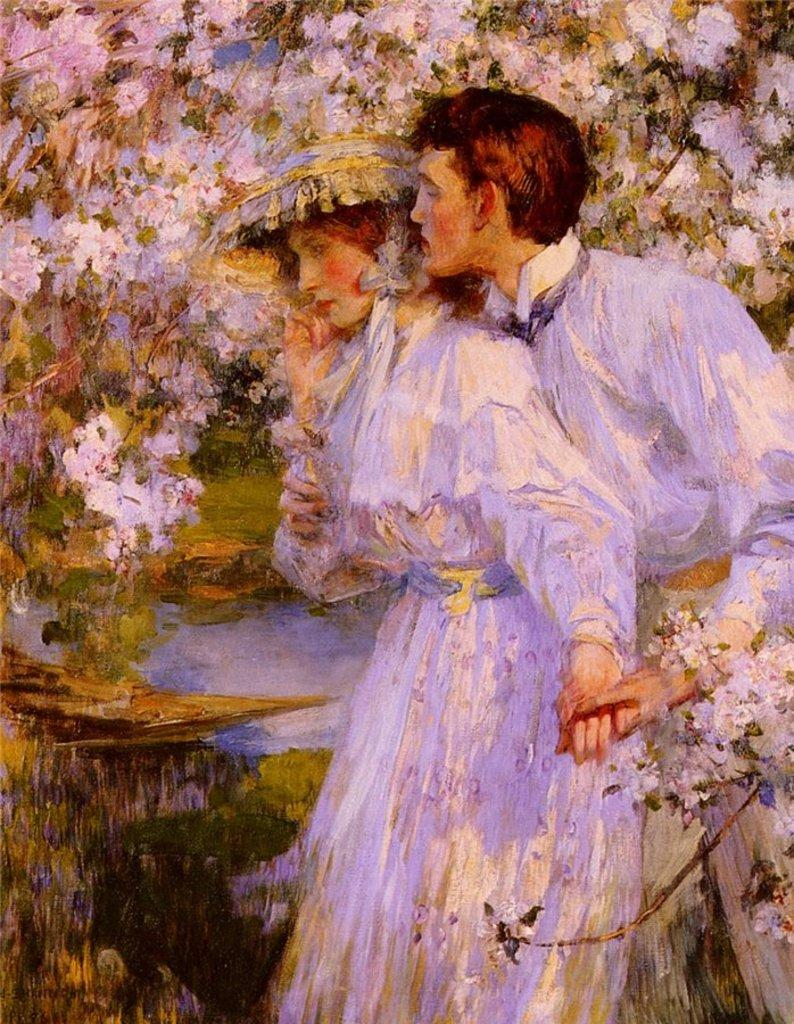What type of artwork is depicted in the image? The image is a painting. Can you describe the subjects in the painting? There is a man and a girl in the painting. The man is standing behind the girl. What is the man doing in the painting? The man is holding the girl's hand in the painting. How is the girl dressed in the painting? The girl is wearing a cap in the painting. What can be seen in the background of the painting? There are flowers and trees in the background of the painting. What type of scarf is the girl wearing in the painting? The girl is not wearing a scarf in the painting; she is wearing a cap. What route does the man take with the girl in the painting? There is no indication of a route or journey in the painting; the man is simply holding the girl's hand. 